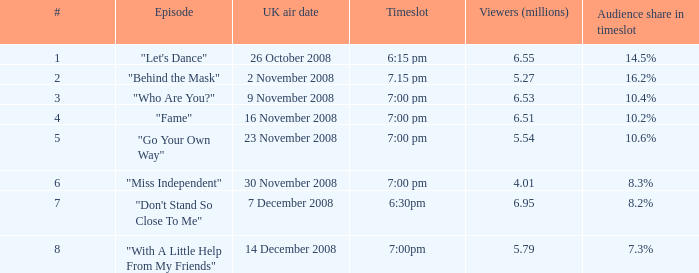Give me the full table as a dictionary. {'header': ['#', 'Episode', 'UK air date', 'Timeslot', 'Viewers (millions)', 'Audience share in timeslot'], 'rows': [['1', '"Let\'s Dance"', '26 October 2008', '6:15 pm', '6.55', '14.5%'], ['2', '"Behind the Mask"', '2 November 2008', '7.15 pm', '5.27', '16.2%'], ['3', '"Who Are You?"', '9 November 2008', '7:00 pm', '6.53', '10.4%'], ['4', '"Fame"', '16 November 2008', '7:00 pm', '6.51', '10.2%'], ['5', '"Go Your Own Way"', '23 November 2008', '7:00 pm', '5.54', '10.6%'], ['6', '"Miss Independent"', '30 November 2008', '7:00 pm', '4.01', '8.3%'], ['7', '"Don\'t Stand So Close To Me"', '7 December 2008', '6:30pm', '6.95', '8.2%'], ['8', '"With A Little Help From My Friends"', '14 December 2008', '7:00pm', '5.79', '7.3%']]} Specify the overall quantity of timeslots for number 1 1.0. 